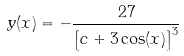Convert formula to latex. <formula><loc_0><loc_0><loc_500><loc_500>y ( x ) = - \frac { 2 7 } { \left [ c + 3 \cos ( x ) \right ] ^ { 3 } }</formula> 